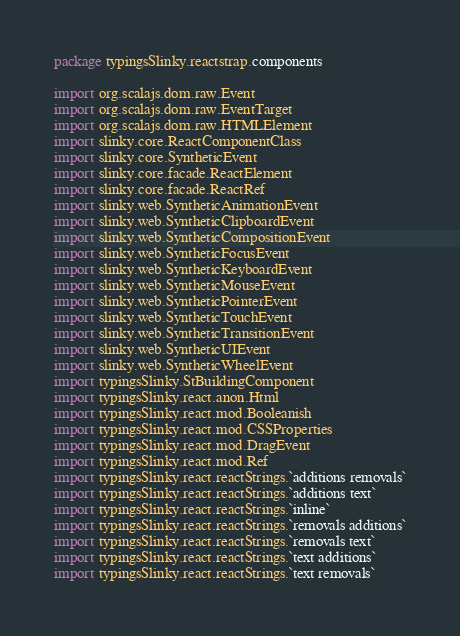Convert code to text. <code><loc_0><loc_0><loc_500><loc_500><_Scala_>package typingsSlinky.reactstrap.components

import org.scalajs.dom.raw.Event
import org.scalajs.dom.raw.EventTarget
import org.scalajs.dom.raw.HTMLElement
import slinky.core.ReactComponentClass
import slinky.core.SyntheticEvent
import slinky.core.facade.ReactElement
import slinky.core.facade.ReactRef
import slinky.web.SyntheticAnimationEvent
import slinky.web.SyntheticClipboardEvent
import slinky.web.SyntheticCompositionEvent
import slinky.web.SyntheticFocusEvent
import slinky.web.SyntheticKeyboardEvent
import slinky.web.SyntheticMouseEvent
import slinky.web.SyntheticPointerEvent
import slinky.web.SyntheticTouchEvent
import slinky.web.SyntheticTransitionEvent
import slinky.web.SyntheticUIEvent
import slinky.web.SyntheticWheelEvent
import typingsSlinky.StBuildingComponent
import typingsSlinky.react.anon.Html
import typingsSlinky.react.mod.Booleanish
import typingsSlinky.react.mod.CSSProperties
import typingsSlinky.react.mod.DragEvent
import typingsSlinky.react.mod.Ref
import typingsSlinky.react.reactStrings.`additions removals`
import typingsSlinky.react.reactStrings.`additions text`
import typingsSlinky.react.reactStrings.`inline`
import typingsSlinky.react.reactStrings.`removals additions`
import typingsSlinky.react.reactStrings.`removals text`
import typingsSlinky.react.reactStrings.`text additions`
import typingsSlinky.react.reactStrings.`text removals`</code> 